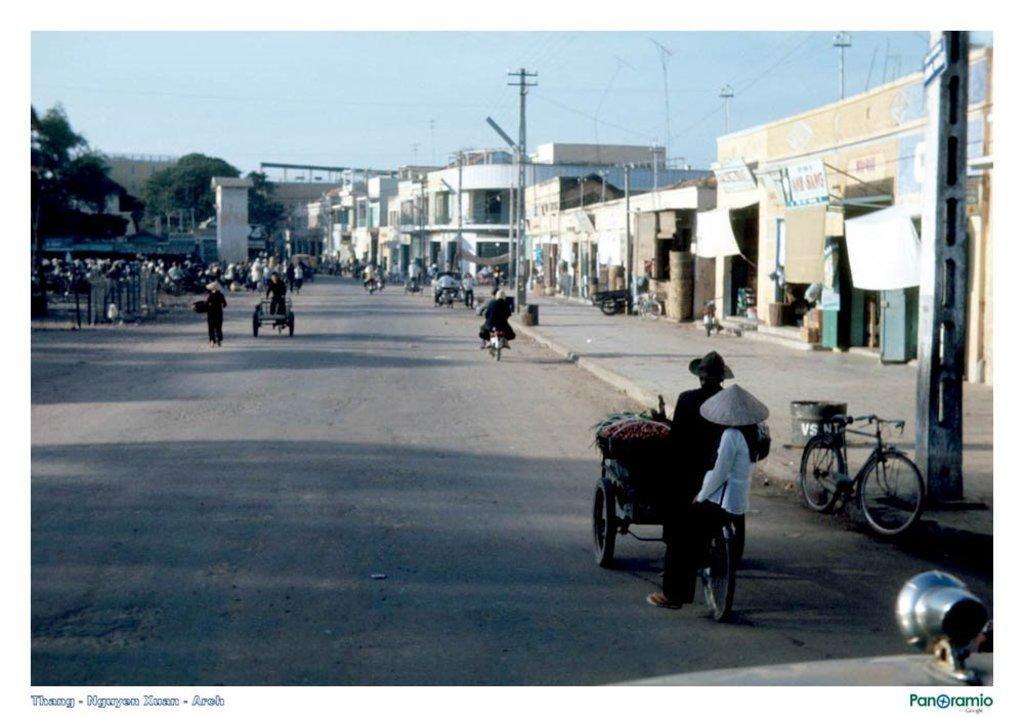How would you summarize this image in a sentence or two? In this picture we can see some people are standing, there are some people riding bikes, we can see rickshaws in the middle, on the right side there are buildings, poles and wires, on the left side we can see trees, there is the sky at the top of the picture, at the right bottom there is some text, we can also see a bicycle on the right side. 